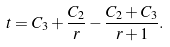<formula> <loc_0><loc_0><loc_500><loc_500>t = C _ { 3 } + \frac { C _ { 2 } } { r } - \frac { C _ { 2 } + C _ { 3 } } { r + 1 } .</formula> 